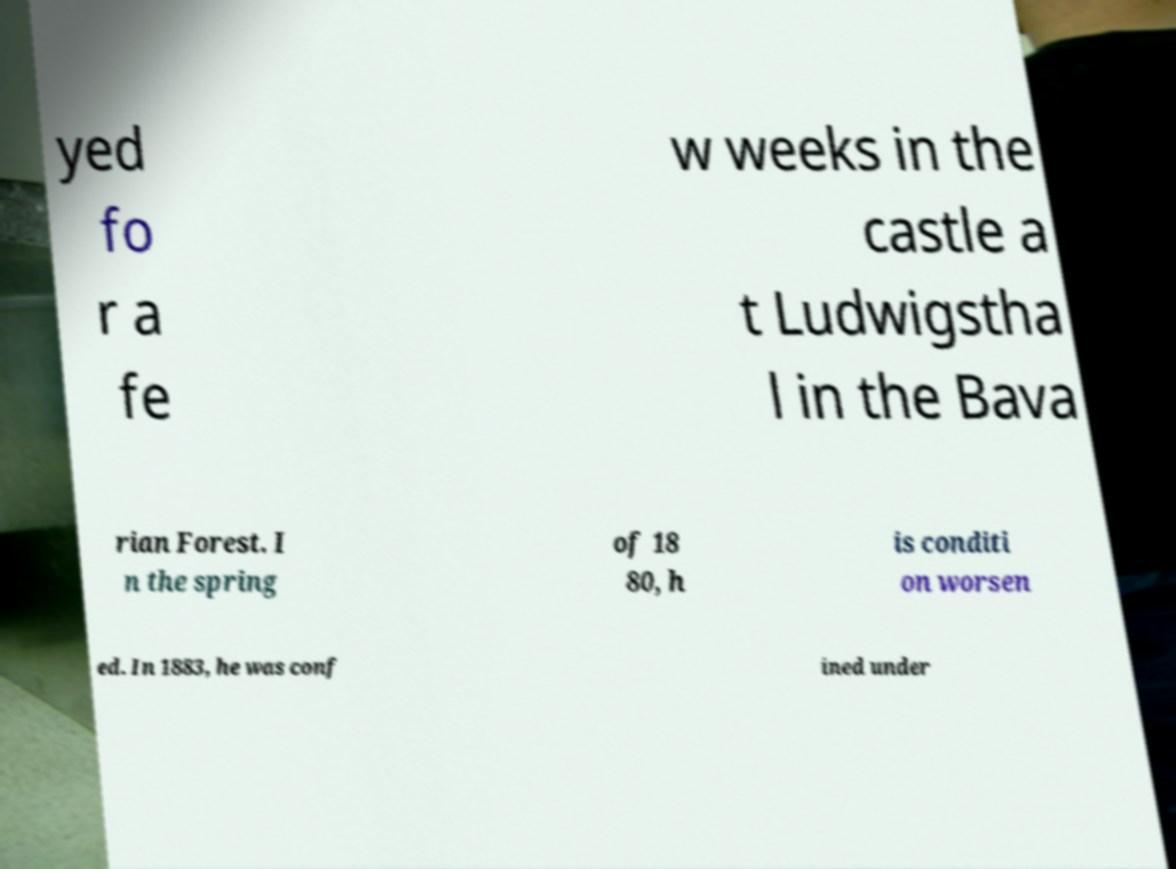Could you assist in decoding the text presented in this image and type it out clearly? yed fo r a fe w weeks in the castle a t Ludwigstha l in the Bava rian Forest. I n the spring of 18 80, h is conditi on worsen ed. In 1883, he was conf ined under 